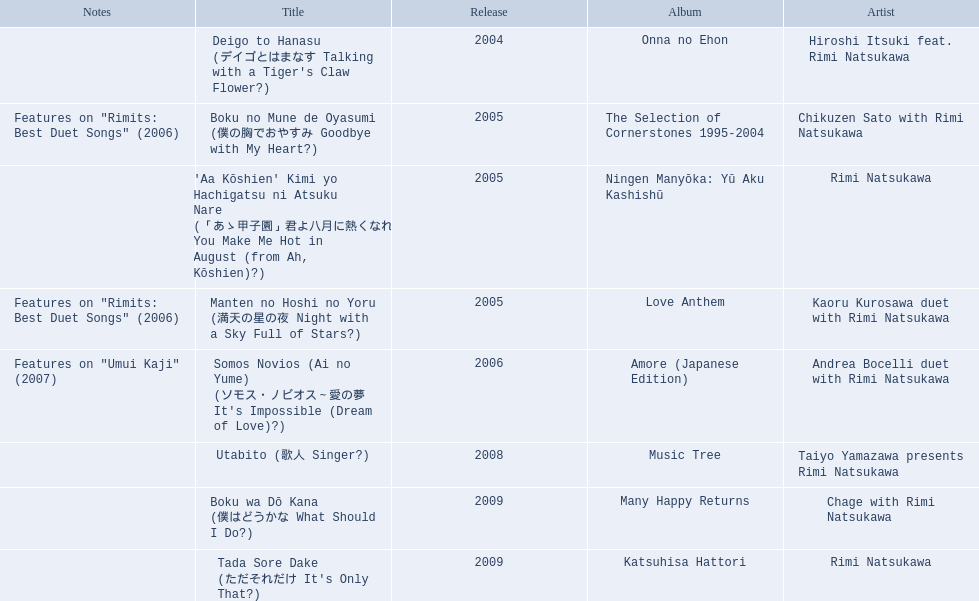Which title of the rimi natsukawa discography was released in the 2004? Deigo to Hanasu (デイゴとはまなす Talking with a Tiger's Claw Flower?). Which title has notes that features on/rimits. best duet songs\2006 Manten no Hoshi no Yoru (満天の星の夜 Night with a Sky Full of Stars?). Which title share the same notes as night with a sky full of stars? Boku no Mune de Oyasumi (僕の胸でおやすみ Goodbye with My Heart?). 